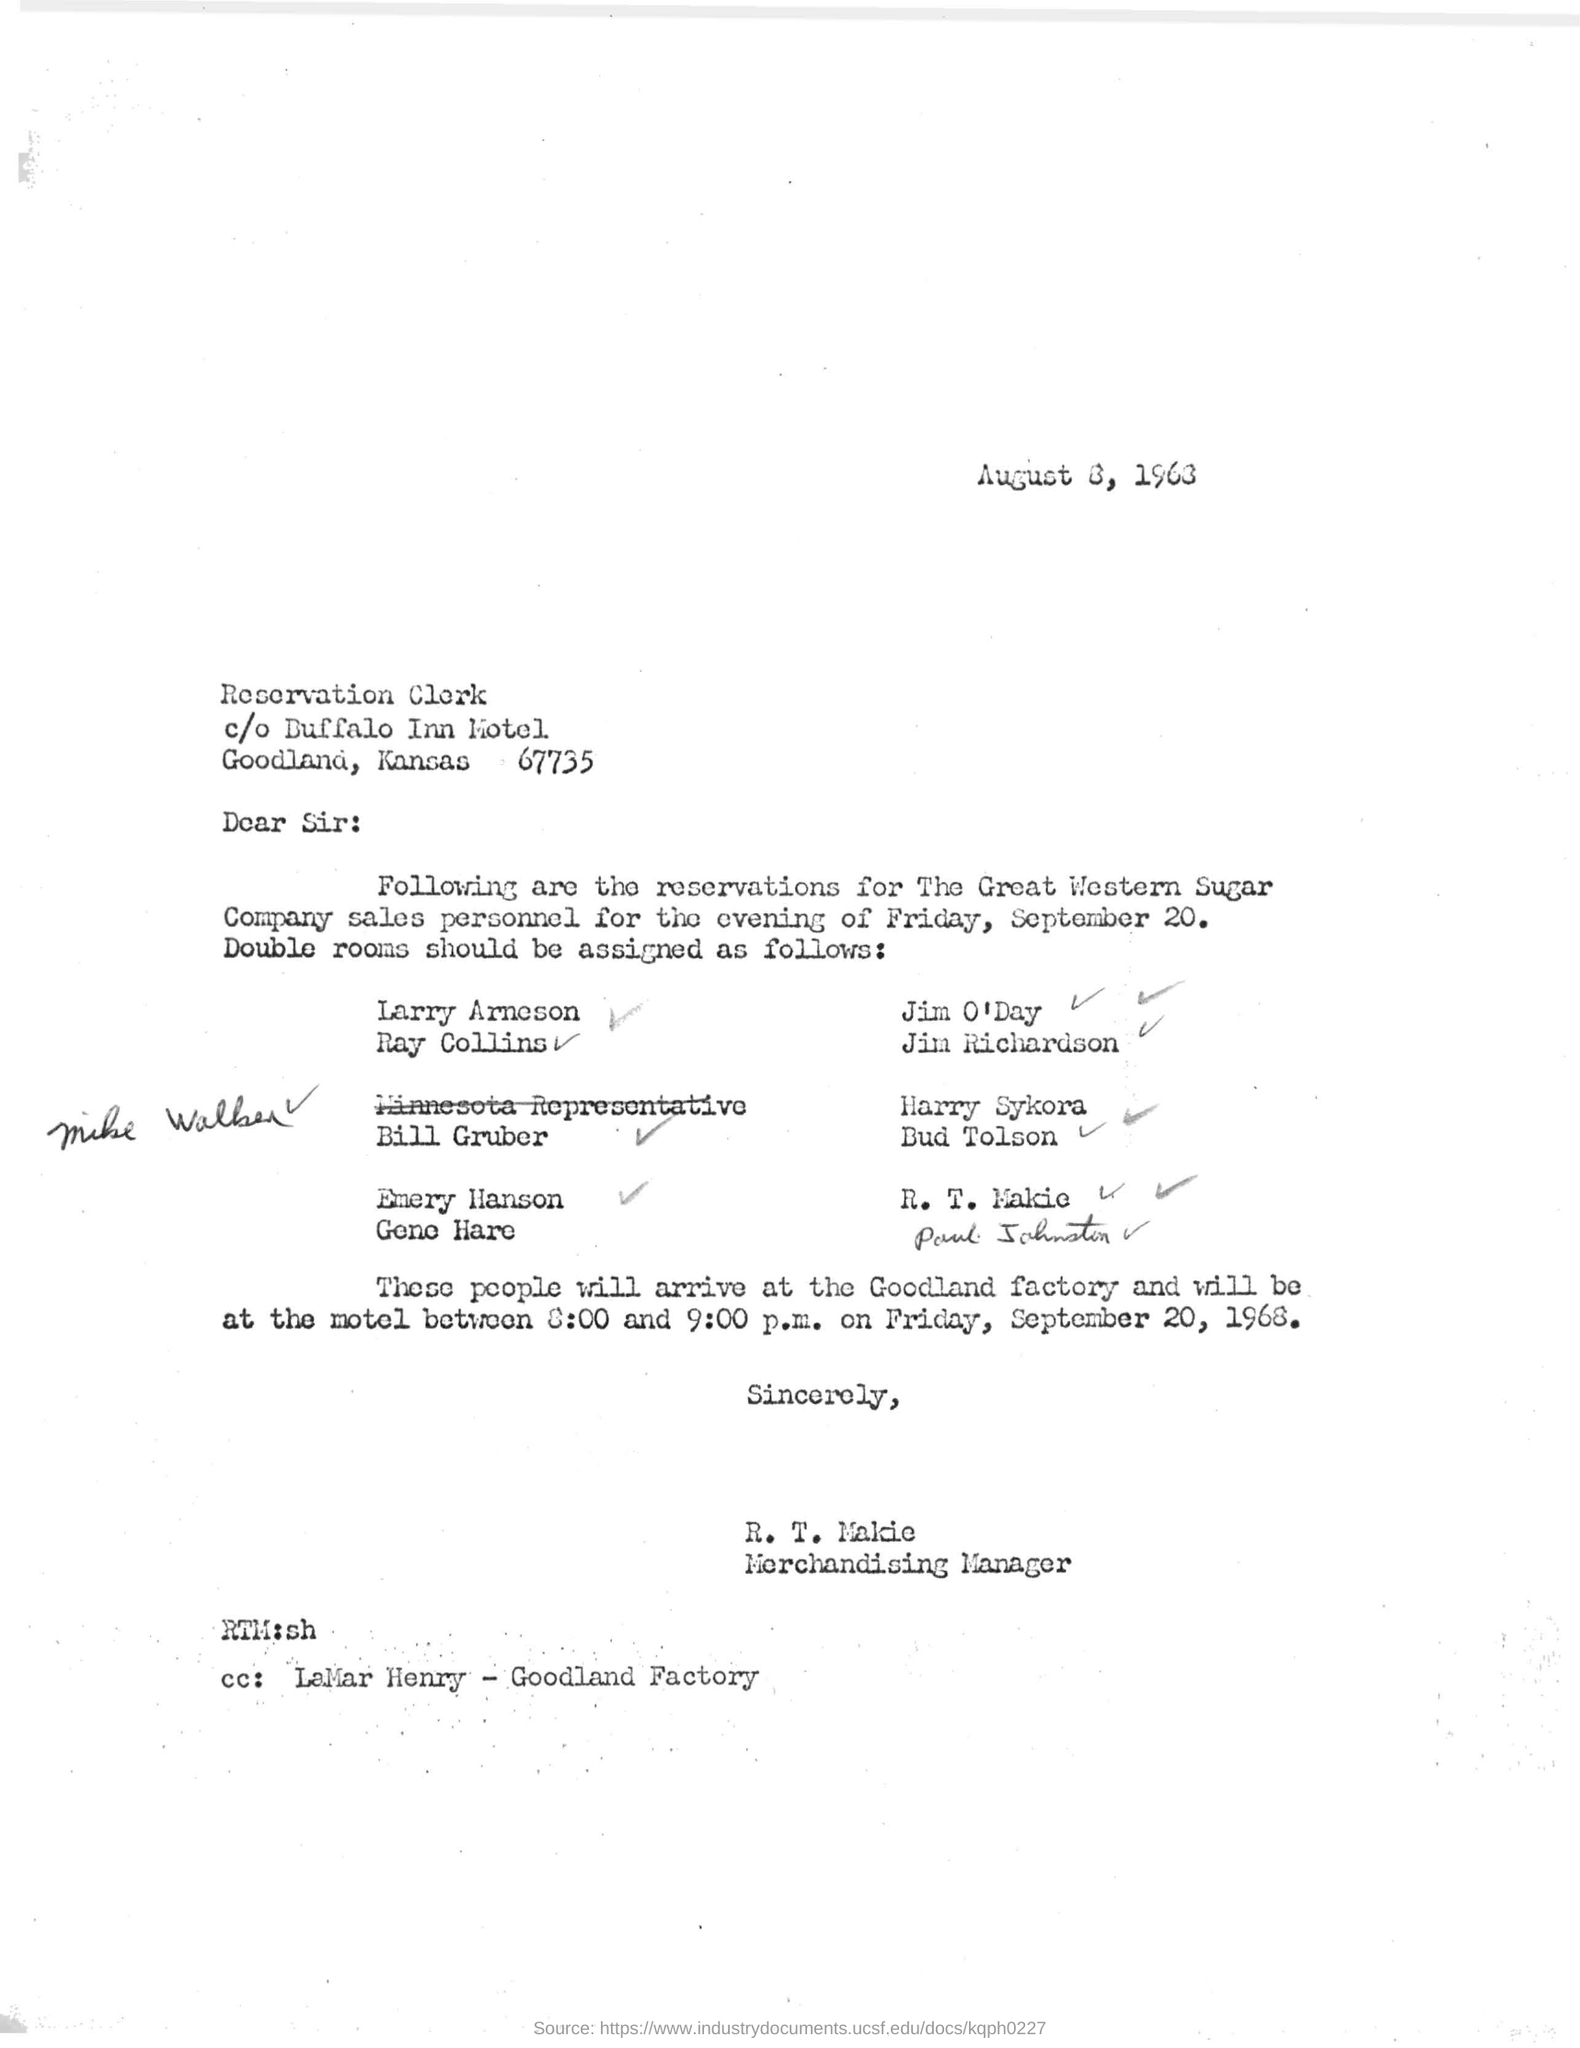Which date is mentioned in this letter?
Offer a terse response. August 8, 1963. What is the reservation date mentioned in this letter?
Provide a short and direct response. Friday, September 20. Who is the sender of this letter?
Make the answer very short. R. T. Makie. What is the designation of the sender?
Your answer should be compact. MERCHANDISING MANAGER. 